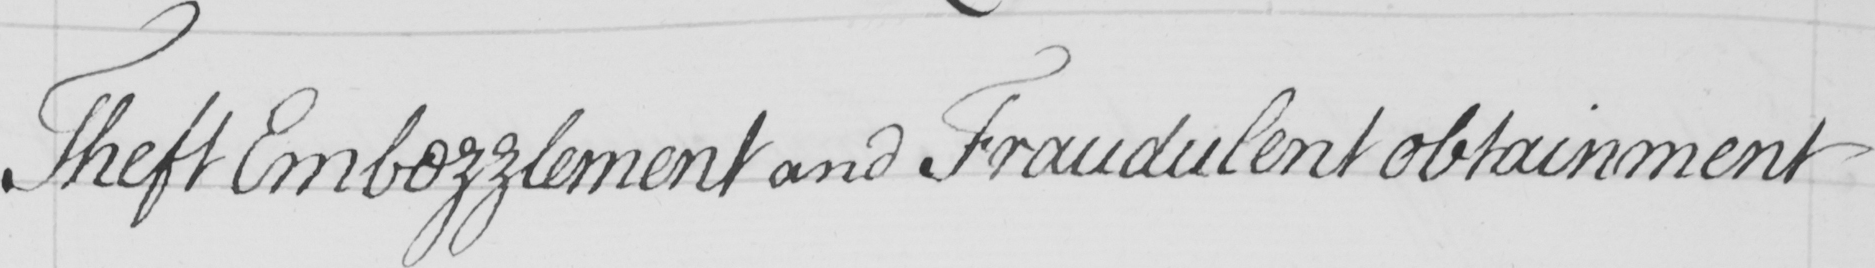Transcribe the text shown in this historical manuscript line. Theft Embezzlement and Fraudulent obtainment 